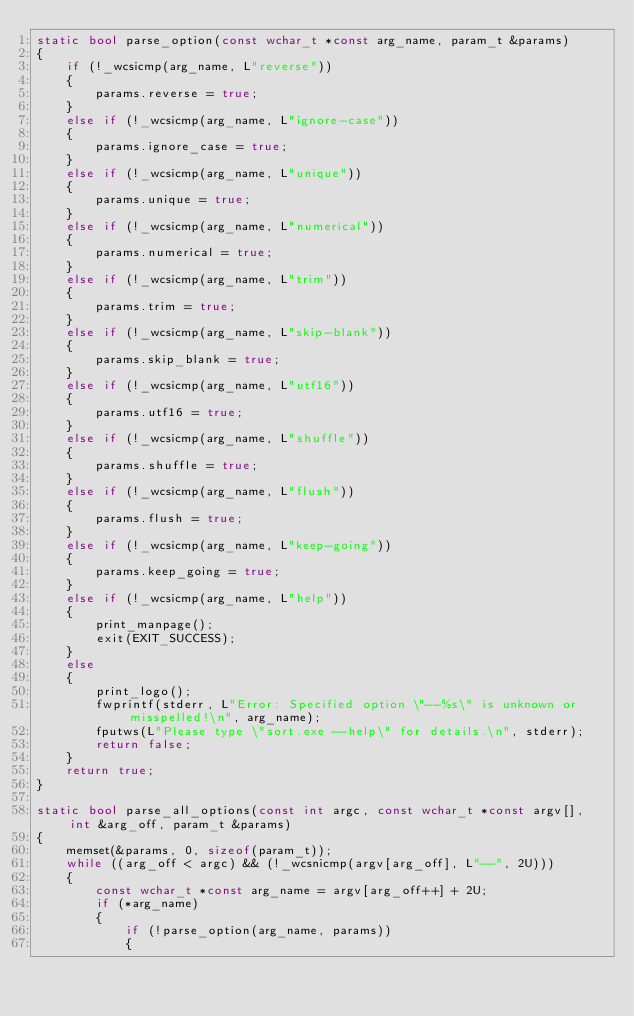Convert code to text. <code><loc_0><loc_0><loc_500><loc_500><_C++_>static bool parse_option(const wchar_t *const arg_name, param_t &params)
{
	if (!_wcsicmp(arg_name, L"reverse"))
	{
		params.reverse = true;
	}
	else if (!_wcsicmp(arg_name, L"ignore-case"))
	{
		params.ignore_case = true;
	}
	else if (!_wcsicmp(arg_name, L"unique"))
	{
		params.unique = true;
	}
	else if (!_wcsicmp(arg_name, L"numerical"))
	{
		params.numerical = true;
	}
	else if (!_wcsicmp(arg_name, L"trim"))
	{
		params.trim = true;
	}
	else if (!_wcsicmp(arg_name, L"skip-blank"))
	{
		params.skip_blank = true;
	}
	else if (!_wcsicmp(arg_name, L"utf16"))
	{
		params.utf16 = true;
	}
	else if (!_wcsicmp(arg_name, L"shuffle"))
	{
		params.shuffle = true;
	}
	else if (!_wcsicmp(arg_name, L"flush"))
	{
		params.flush = true;
	}
	else if (!_wcsicmp(arg_name, L"keep-going"))
	{
		params.keep_going = true;
	}
	else if (!_wcsicmp(arg_name, L"help"))
	{
		print_manpage();
		exit(EXIT_SUCCESS);
	}
	else
	{
		print_logo();
		fwprintf(stderr, L"Error: Specified option \"--%s\" is unknown or misspelled!\n", arg_name);
		fputws(L"Please type \"sort.exe --help\" for details.\n", stderr);
		return false;
	}
	return true;
}

static bool parse_all_options(const int argc, const wchar_t *const argv[], int &arg_off, param_t &params)
{
	memset(&params, 0, sizeof(param_t));
	while ((arg_off < argc) && (!_wcsnicmp(argv[arg_off], L"--", 2U)))
	{
		const wchar_t *const arg_name = argv[arg_off++] + 2U;
		if (*arg_name)
		{
			if (!parse_option(arg_name, params))
			{</code> 